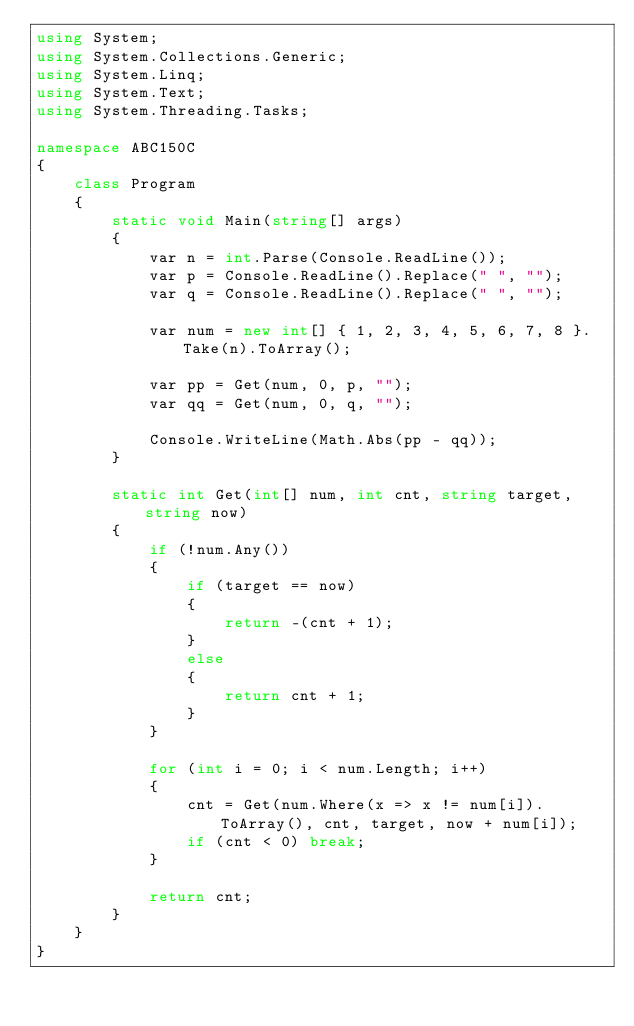Convert code to text. <code><loc_0><loc_0><loc_500><loc_500><_C#_>using System;
using System.Collections.Generic;
using System.Linq;
using System.Text;
using System.Threading.Tasks;

namespace ABC150C
{
    class Program
    {
        static void Main(string[] args)
        {
            var n = int.Parse(Console.ReadLine());
            var p = Console.ReadLine().Replace(" ", "");
            var q = Console.ReadLine().Replace(" ", "");

            var num = new int[] { 1, 2, 3, 4, 5, 6, 7, 8 }.Take(n).ToArray();

            var pp = Get(num, 0, p, "");
            var qq = Get(num, 0, q, "");

            Console.WriteLine(Math.Abs(pp - qq));
        }

        static int Get(int[] num, int cnt, string target, string now)
        {
            if (!num.Any())
            {
                if (target == now)
                {
                    return -(cnt + 1);
                }
                else
                {
                    return cnt + 1;
                }
            }

            for (int i = 0; i < num.Length; i++)
            {
                cnt = Get(num.Where(x => x != num[i]).ToArray(), cnt, target, now + num[i]);
                if (cnt < 0) break;
            }

            return cnt;
        }
    }
}
</code> 